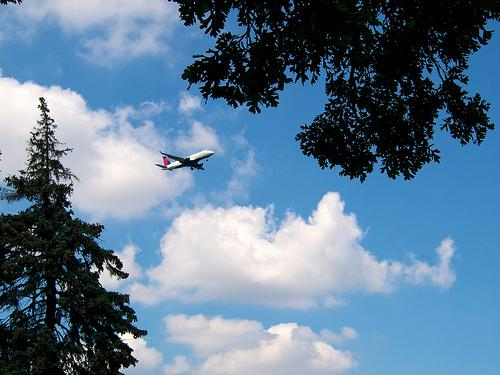Describe the setting where the primary subject of the image is located. The setting is a bright daylight sky with white, fluffy clouds and a tall pine tree filling the scene. Mention the primary object in the image and its color. The primary object is a white plane with a red and blue tail, flying in the sky. Mention the primary object in the image and its distinctive features. The primary object is a white airplane with a painted red and blue tail, landing wheels down, and flying in the sky. Describe what the main object in the picture looks like and its location. A white plane with a red and blue tail is soaring in the sky, surrounded by clouds and a tall tree. Create a short sentence describing the main elements of the image. An airplane with a colorful tail flies gracefully in a cloud-filled sky near a towering, evergreen pine tree. Detail the environment in which the central object is present in the image. The airplane is cruising in a blue sky with fluffy white clouds and a tall, evergreen pine tree nearby. Express the primary atmosphere of the image in a short statement. A serene day with a bright airplane set against a partially clouded sky. Choose three main objects in the image and describe them briefly. A white, delta airlines airplane with a red and blue tail, wheels down, flying past a tall pine tree amidst white puffy clouds. State the activity happening in the image by focusing on the main subject. An airplane with its wheels out is flying in the sky above a tree and amidst white clouds. Describe the scene in the image by focusing on the main subject and its surroundings. A white plane with a red and blue tail is flying high in the partly cloudy, blue sky, near a tall pine tree with green needles. 